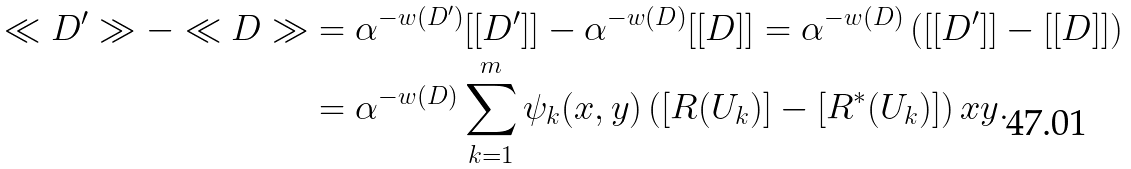Convert formula to latex. <formula><loc_0><loc_0><loc_500><loc_500>\ll D ^ { \prime } \gg - \ll D \gg & = \alpha ^ { - w ( D ^ { \prime } ) } [ [ D ^ { \prime } ] ] - \alpha ^ { - w ( D ) } [ [ D ] ] = \alpha ^ { - w ( D ) } \left ( [ [ D ^ { \prime } ] ] - [ [ D ] ] \right ) \\ & = \alpha ^ { - w ( D ) } \sum _ { k = 1 } ^ { m } \psi _ { k } ( x , y ) \left ( [ R ( U _ { k } ) ] - [ R ^ { * } ( U _ { k } ) ] \right ) x y .</formula> 